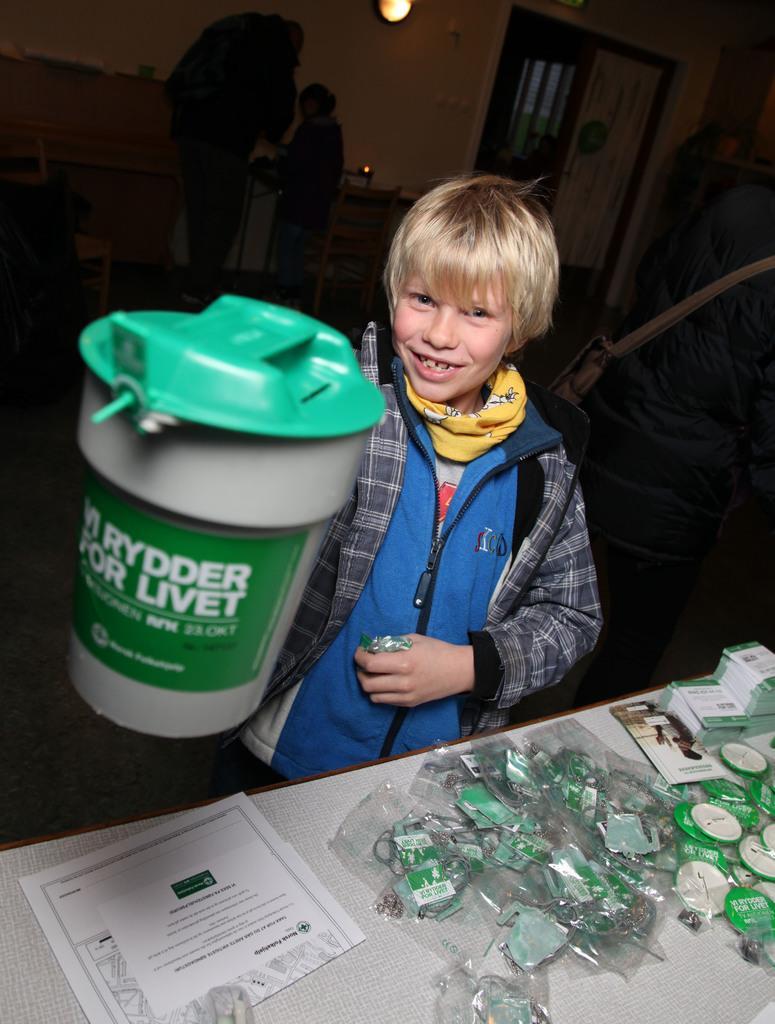Can you describe this image briefly? In this picture I can see a paper and few items on the table and I can see a boy holding a plastic container in his hand and he is holding something in another hand and I can see couple of them standing in the back and I can see a light. 